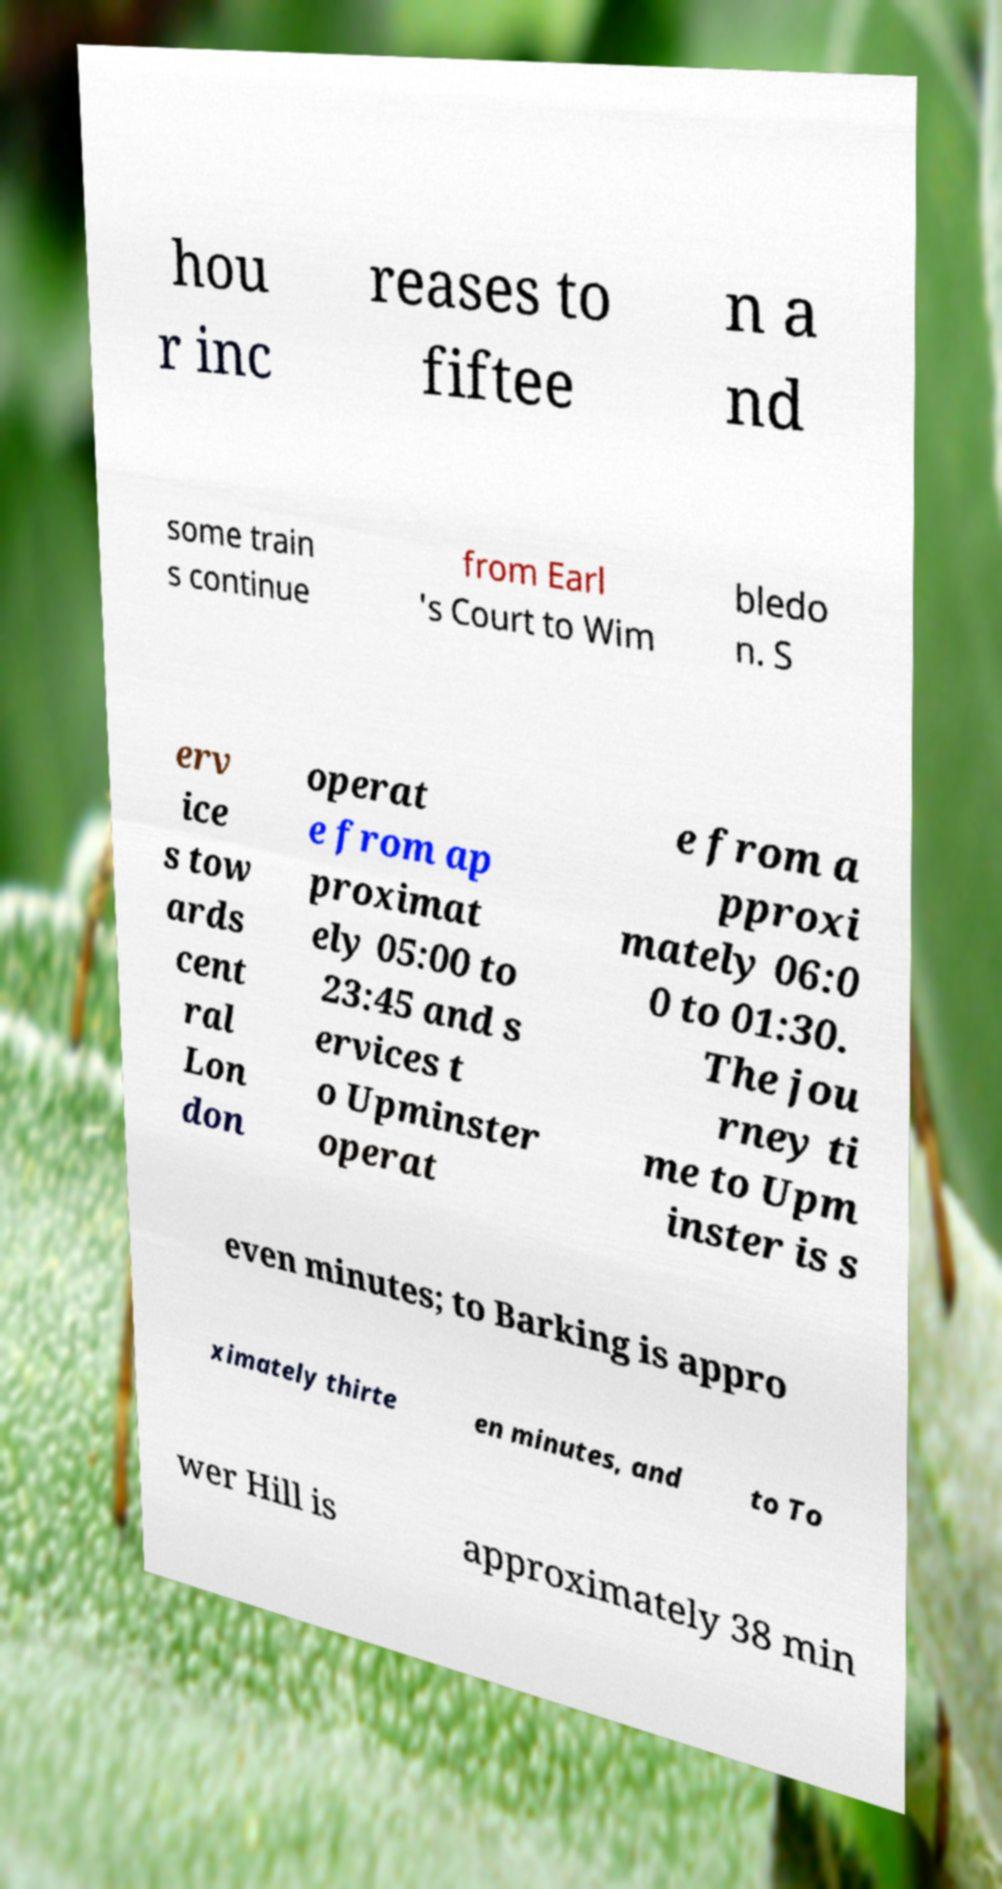Please read and relay the text visible in this image. What does it say? hou r inc reases to fiftee n a nd some train s continue from Earl 's Court to Wim bledo n. S erv ice s tow ards cent ral Lon don operat e from ap proximat ely 05:00 to 23:45 and s ervices t o Upminster operat e from a pproxi mately 06:0 0 to 01:30. The jou rney ti me to Upm inster is s even minutes; to Barking is appro ximately thirte en minutes, and to To wer Hill is approximately 38 min 